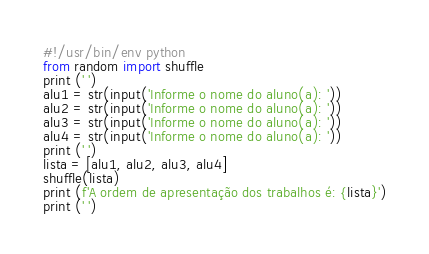<code> <loc_0><loc_0><loc_500><loc_500><_Python_>#!/usr/bin/env python
from random import shuffle
print (' ')
alu1 = str(input('Informe o nome do aluno(a): '))
alu2 = str(input('Informe o nome do aluno(a): '))
alu3 = str(input('Informe o nome do aluno(a): '))
alu4 = str(input('Informe o nome do aluno(a): '))
print (' ')
lista = [alu1, alu2, alu3, alu4]
shuffle(lista)
print (f'A ordem de apresentação dos trabalhos é: {lista}')
print (' ')</code> 